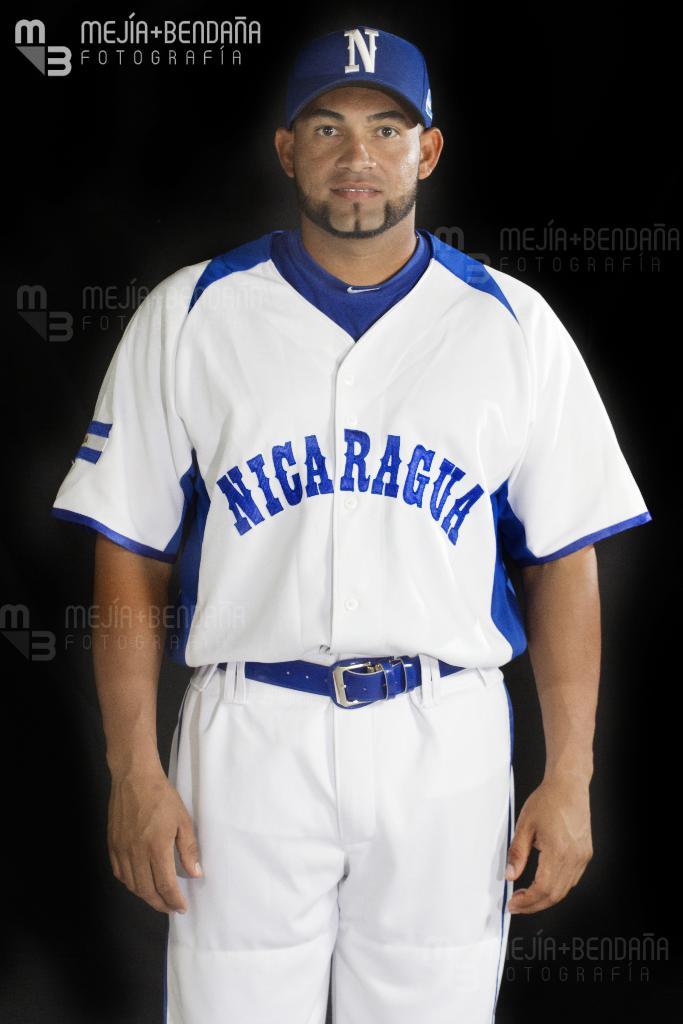What letter is on the player's cap?
Give a very brief answer. N. 